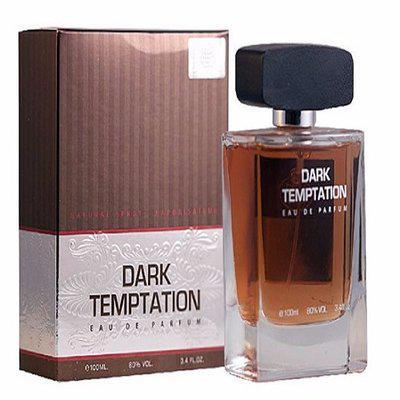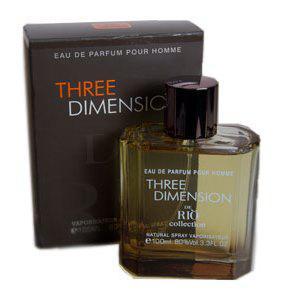The first image is the image on the left, the second image is the image on the right. Examine the images to the left and right. Is the description "The box in each picture is black" accurate? Answer yes or no. No. 